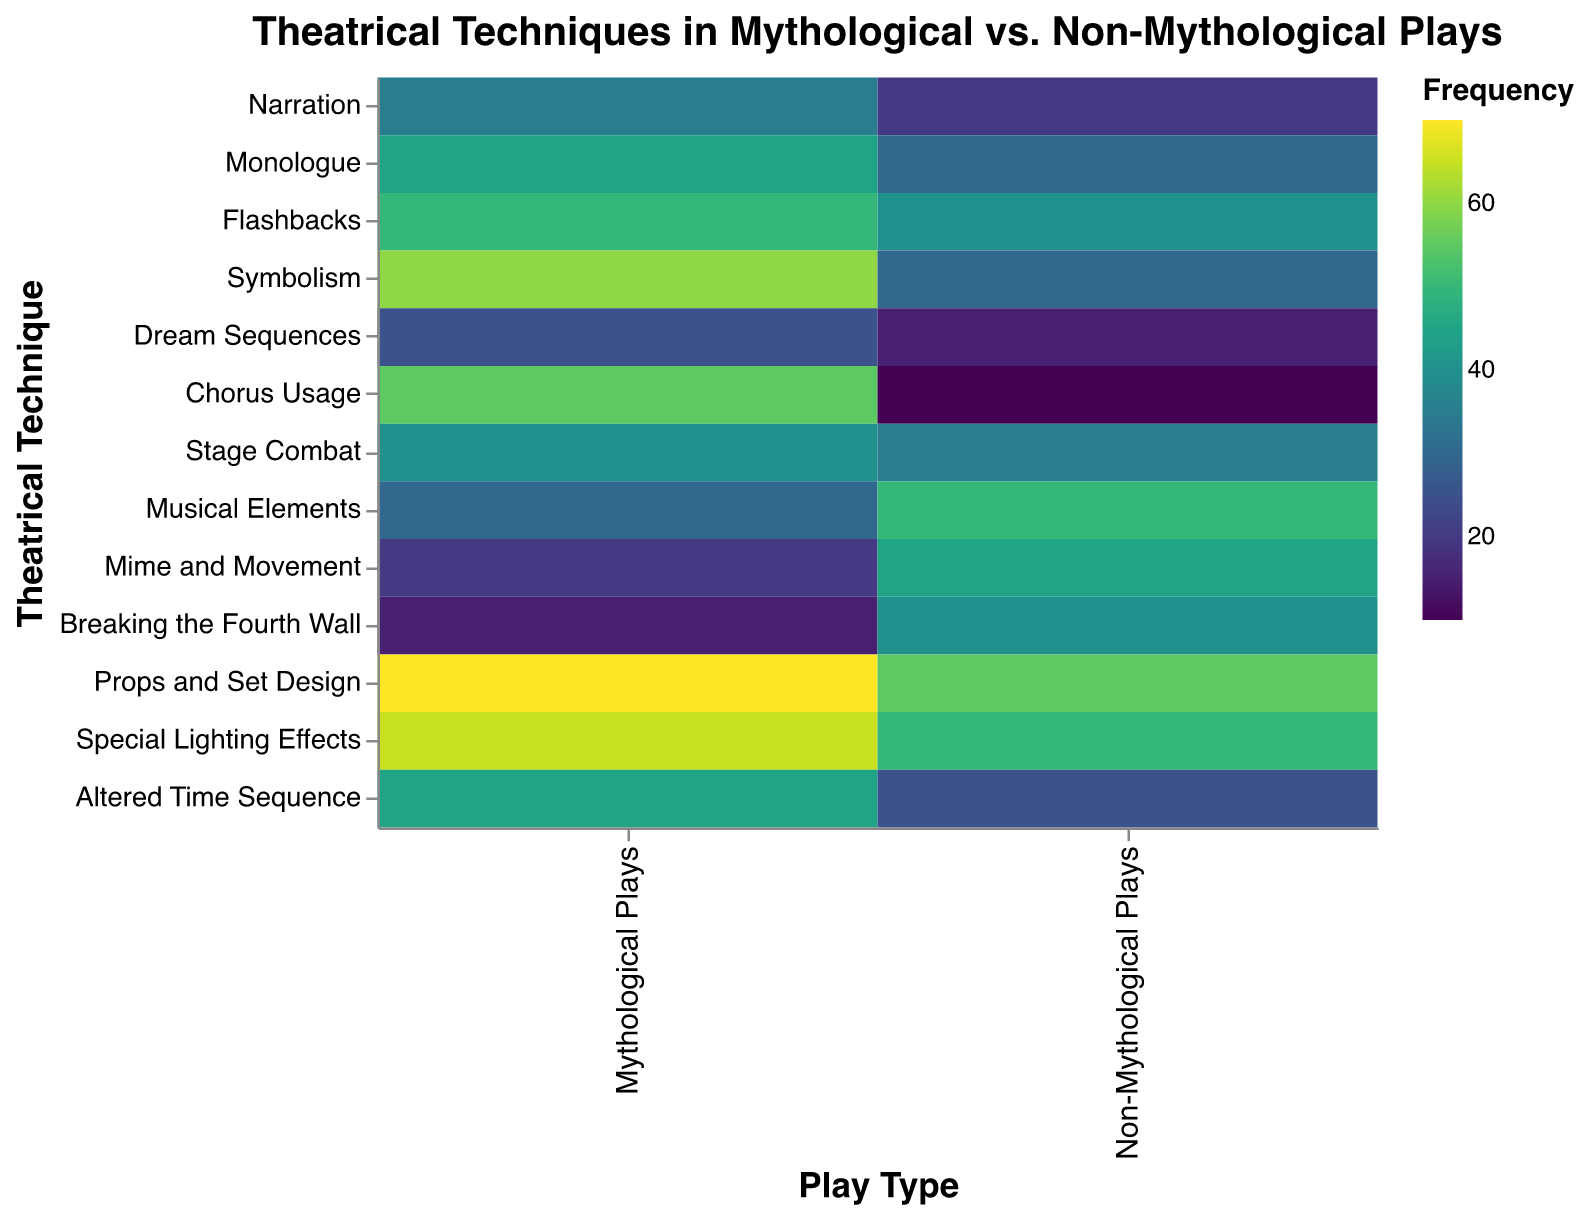What is the title of the heatmap? The title of the heatmap is displayed at the top in larger and bold font for clarity.
Answer: Theatrical Techniques in Mythological vs. Non-Mythological Plays How many types of plays are compared in the heatmap? The x-axis of the heatmap shows two categories which the data belongs to.
Answer: 2 Which theatrical technique has the highest frequency in Mythological Plays? By looking at the darkest cell in the "Mythological Plays" column, we can identify the highest frequency.
Answer: Props and Set Design Which theatrical technique has the lowest frequency in Non-Mythological Plays? By identifying the lightest cell in the "Non-Mythological Plays" column, we can find the lowest frequency.
Answer: Chorus Usage What is the frequency range of Symbolism in both types of plays? By referring to both cells corresponding to Symbolism in the columns of Mythological Plays and Non-Mythological Plays.
Answer: 30 to 60 How does the usage of Mime and Movement in Mythological Plays compare to Non-Mythological Plays? Compare the corresponding cells for "Mime and Movement" in both columns.
Answer: Lower in Mythological Plays Which play type uses Special Lighting Effects more frequently? Compare the frequency values of Special Lighting Effects in both columns and find which is higher.
Answer: Mythological Plays What is the average frequency of Flashbacks and Monologue in Mythological Plays? Calculate the sum of frequencies for Flashbacks and Monologue, then divide by 2.
Answer: 47.5 Of the theatrical techniques listed, which ones have a higher frequency in Mythological Plays compared to Non-Mythological Plays? Compare each technique's frequency value in both columns and select those higher in Mythological Plays.
Answer: Narration, Monologue, Flashbacks, Symbolism, Dream Sequences, Chorus Usage, Stage Combat, Props and Set Design, Special Lighting Effects, Altered Time Sequence Which theatrical techniques are used more frequently in Non-Mythological Plays than in Mythological Plays? Identify and compare each technique's frequency values, selecting those higher in Non-Mythological Plays.
Answer: Musical Elements, Mime and Movement, Breaking the Fourth Wall 